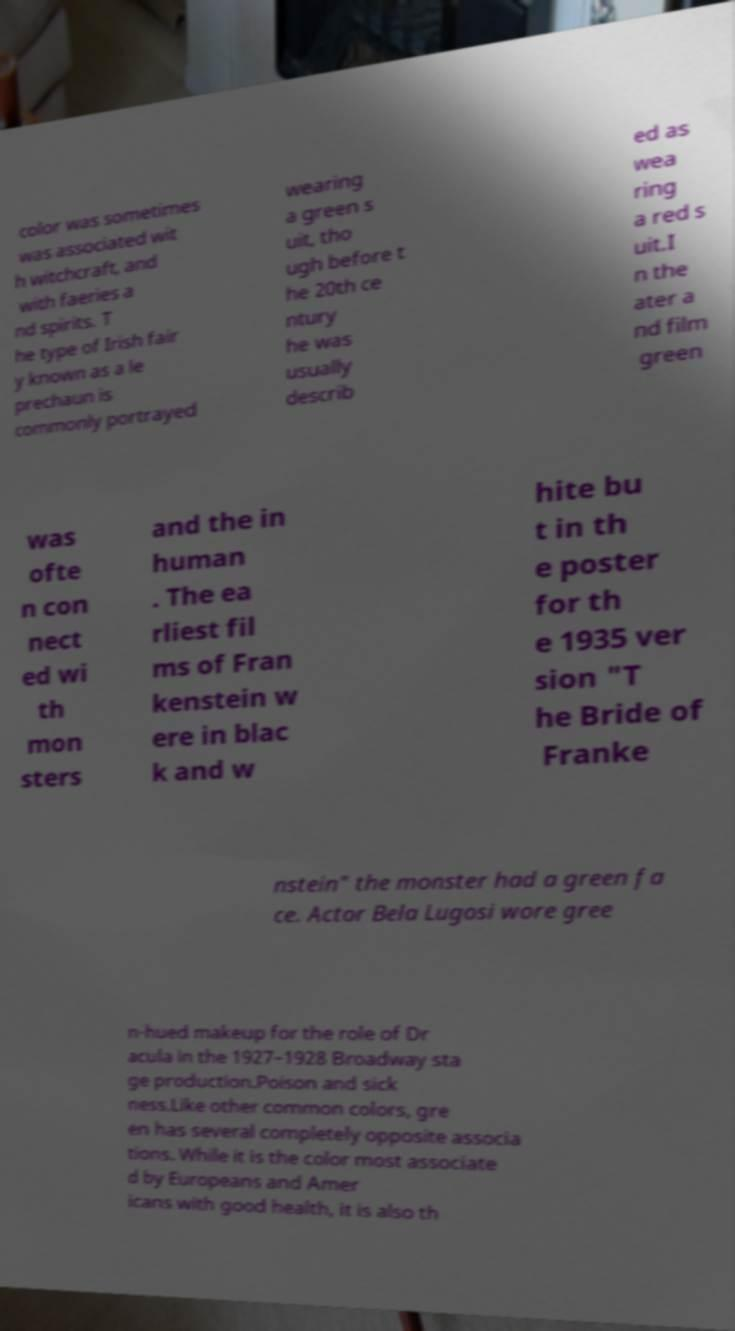Can you read and provide the text displayed in the image?This photo seems to have some interesting text. Can you extract and type it out for me? color was sometimes was associated wit h witchcraft, and with faeries a nd spirits. T he type of Irish fair y known as a le prechaun is commonly portrayed wearing a green s uit, tho ugh before t he 20th ce ntury he was usually describ ed as wea ring a red s uit.I n the ater a nd film green was ofte n con nect ed wi th mon sters and the in human . The ea rliest fil ms of Fran kenstein w ere in blac k and w hite bu t in th e poster for th e 1935 ver sion "T he Bride of Franke nstein" the monster had a green fa ce. Actor Bela Lugosi wore gree n-hued makeup for the role of Dr acula in the 1927–1928 Broadway sta ge production.Poison and sick ness.Like other common colors, gre en has several completely opposite associa tions. While it is the color most associate d by Europeans and Amer icans with good health, it is also th 